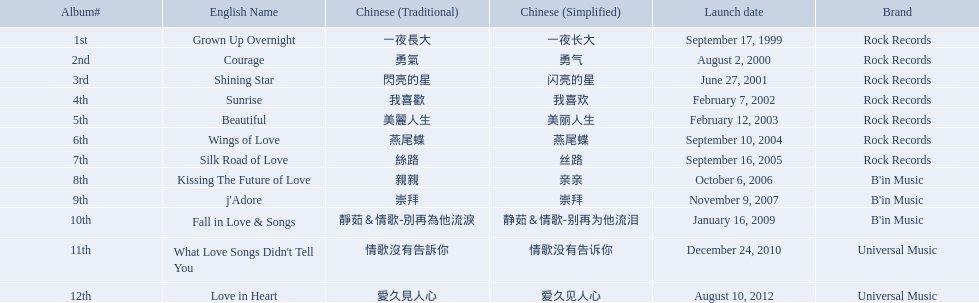Which songs did b'in music produce? Kissing The Future of Love, j'Adore, Fall in Love & Songs. Which one was released in an even numbered year? Kissing The Future of Love. 